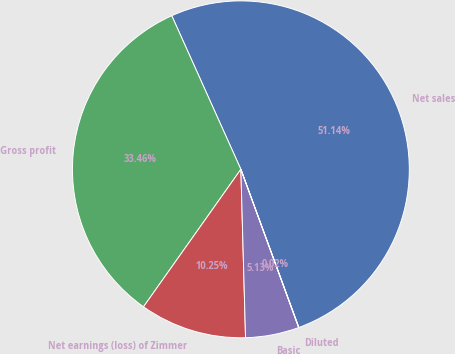Convert chart to OTSL. <chart><loc_0><loc_0><loc_500><loc_500><pie_chart><fcel>Net sales<fcel>Gross profit<fcel>Net earnings (loss) of Zimmer<fcel>Basic<fcel>Diluted<nl><fcel>51.13%<fcel>33.46%<fcel>10.25%<fcel>5.13%<fcel>0.02%<nl></chart> 